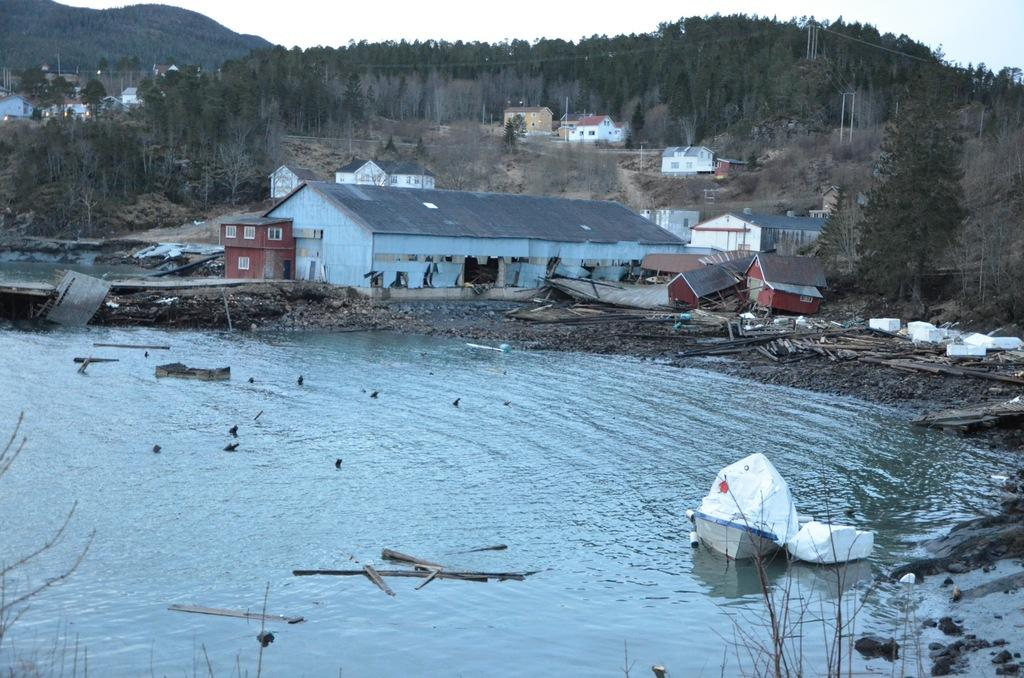What is the main subject of the image? The main subject of the image is a boat. What can be seen in the water near the boat? There are sticks visible in the water near the boat. What type of environment is depicted in the image? The image shows a water environment with buildings, trees, poles, and mountains. What is visible in the background of the image? The sky is visible in the background of the image. Can you describe any objects present in the image? There are some objects in the image, but their specific nature is not mentioned in the facts. What invention is being demonstrated by the zephyr in the image? There is no mention of a zephyr or any invention in the image. 